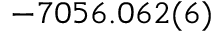<formula> <loc_0><loc_0><loc_500><loc_500>- 7 0 5 6 . 0 6 2 ( 6 )</formula> 